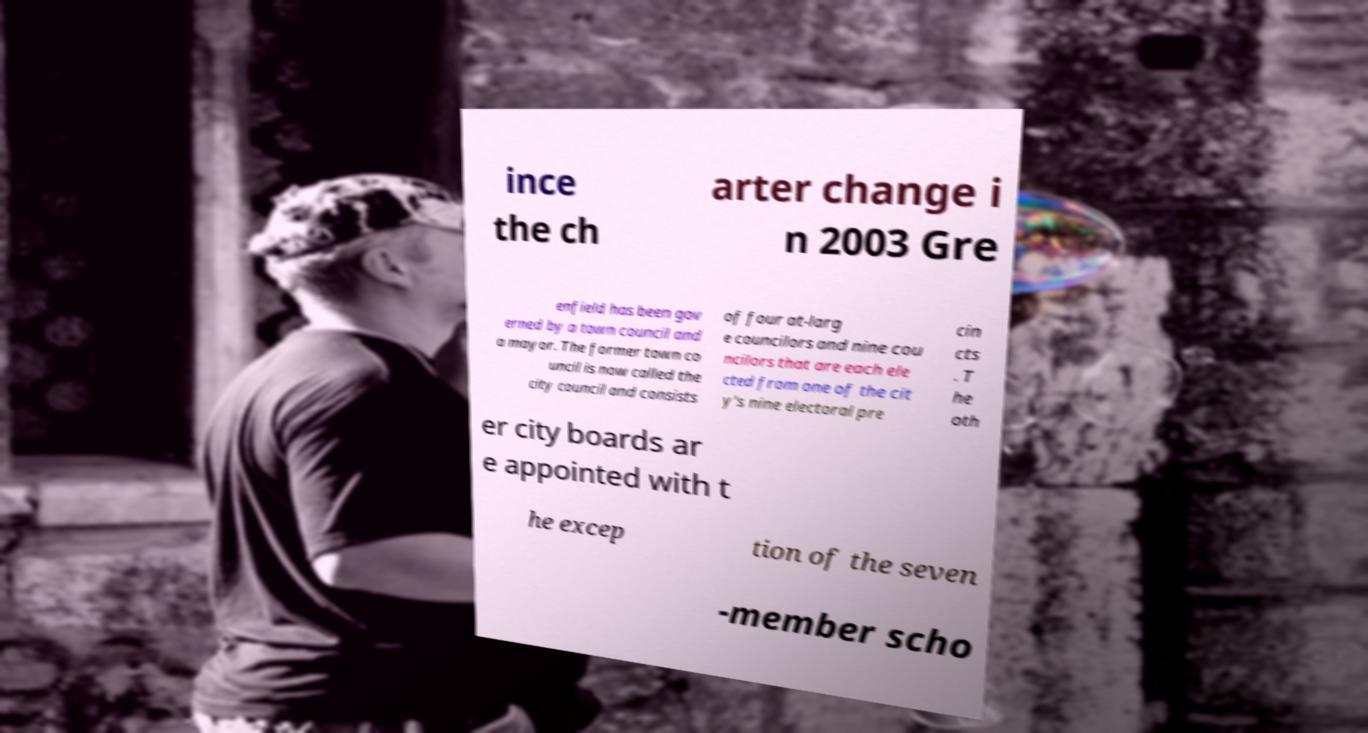What messages or text are displayed in this image? I need them in a readable, typed format. ince the ch arter change i n 2003 Gre enfield has been gov erned by a town council and a mayor. The former town co uncil is now called the city council and consists of four at-larg e councilors and nine cou ncilors that are each ele cted from one of the cit y's nine electoral pre cin cts . T he oth er city boards ar e appointed with t he excep tion of the seven -member scho 